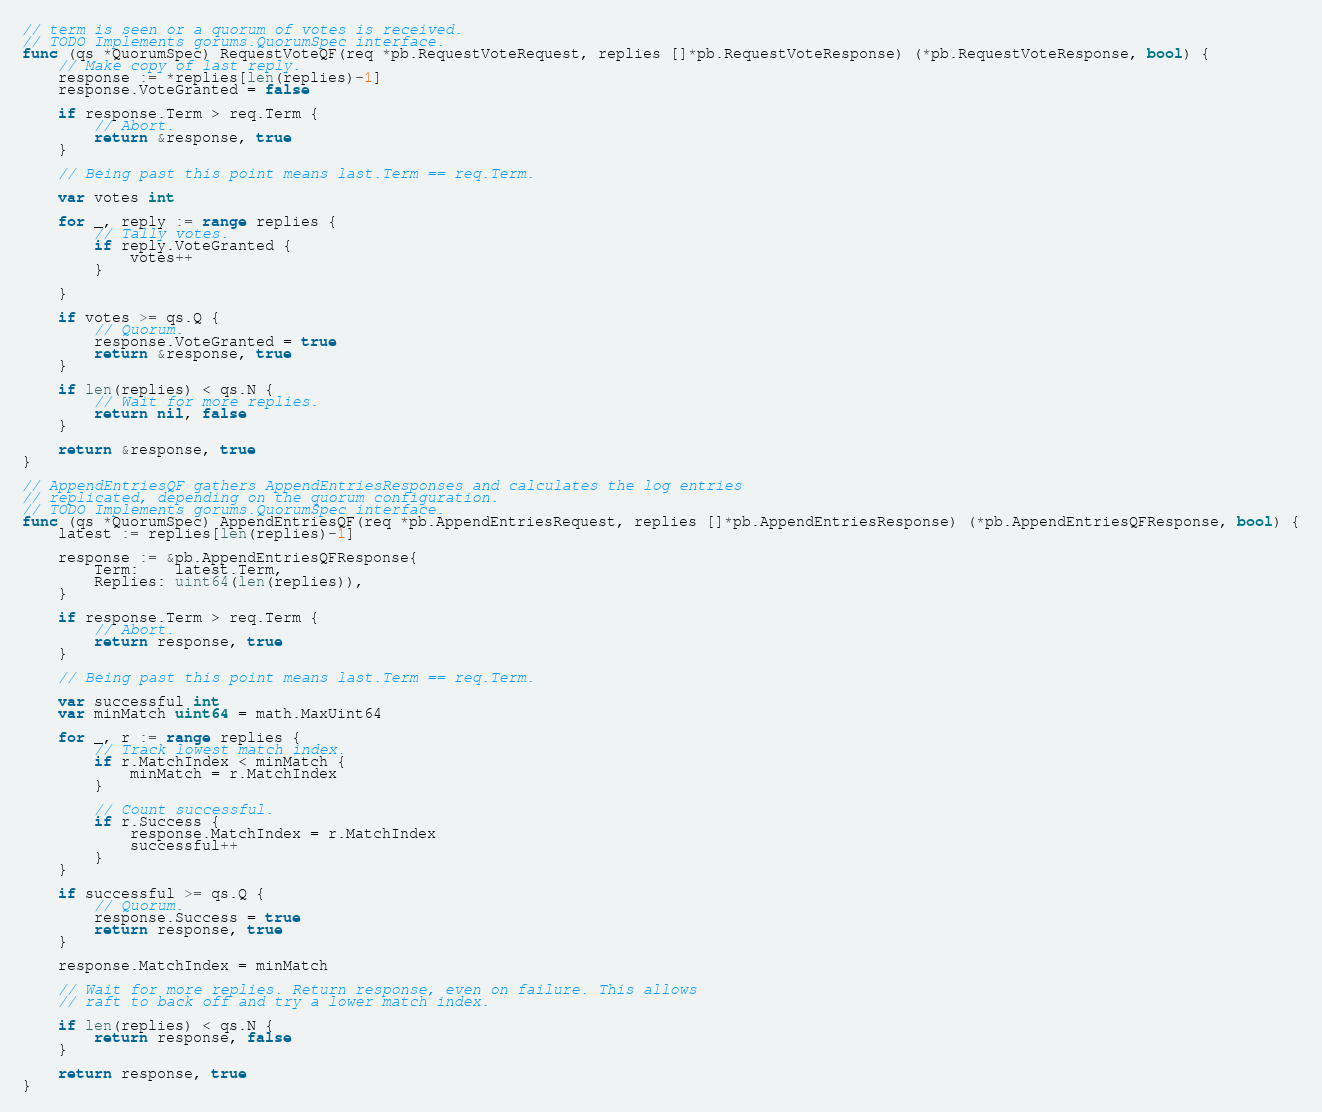<code> <loc_0><loc_0><loc_500><loc_500><_Go_>// term is seen or a quorum of votes is received.
// TODO Implements gorums.QuorumSpec interface.
func (qs *QuorumSpec) RequestVoteQF(req *pb.RequestVoteRequest, replies []*pb.RequestVoteResponse) (*pb.RequestVoteResponse, bool) {
	// Make copy of last reply.
	response := *replies[len(replies)-1]
	response.VoteGranted = false

	if response.Term > req.Term {
		// Abort.
		return &response, true
	}

	// Being past this point means last.Term == req.Term.

	var votes int

	for _, reply := range replies {
		// Tally votes.
		if reply.VoteGranted {
			votes++
		}

	}

	if votes >= qs.Q {
		// Quorum.
		response.VoteGranted = true
		return &response, true
	}

	if len(replies) < qs.N {
		// Wait for more replies.
		return nil, false
	}

	return &response, true
}

// AppendEntriesQF gathers AppendEntriesResponses and calculates the log entries
// replicated, depending on the quorum configuration.
// TODO Implements gorums.QuorumSpec interface.
func (qs *QuorumSpec) AppendEntriesQF(req *pb.AppendEntriesRequest, replies []*pb.AppendEntriesResponse) (*pb.AppendEntriesQFResponse, bool) {
	latest := replies[len(replies)-1]

	response := &pb.AppendEntriesQFResponse{
		Term:    latest.Term,
		Replies: uint64(len(replies)),
	}

	if response.Term > req.Term {
		// Abort.
		return response, true
	}

	// Being past this point means last.Term == req.Term.

	var successful int
	var minMatch uint64 = math.MaxUint64

	for _, r := range replies {
		// Track lowest match index.
		if r.MatchIndex < minMatch {
			minMatch = r.MatchIndex
		}

		// Count successful.
		if r.Success {
			response.MatchIndex = r.MatchIndex
			successful++
		}
	}

	if successful >= qs.Q {
		// Quorum.
		response.Success = true
		return response, true
	}

	response.MatchIndex = minMatch

	// Wait for more replies. Return response, even on failure. This allows
	// raft to back off and try a lower match index.

	if len(replies) < qs.N {
		return response, false
	}

	return response, true
}
</code> 